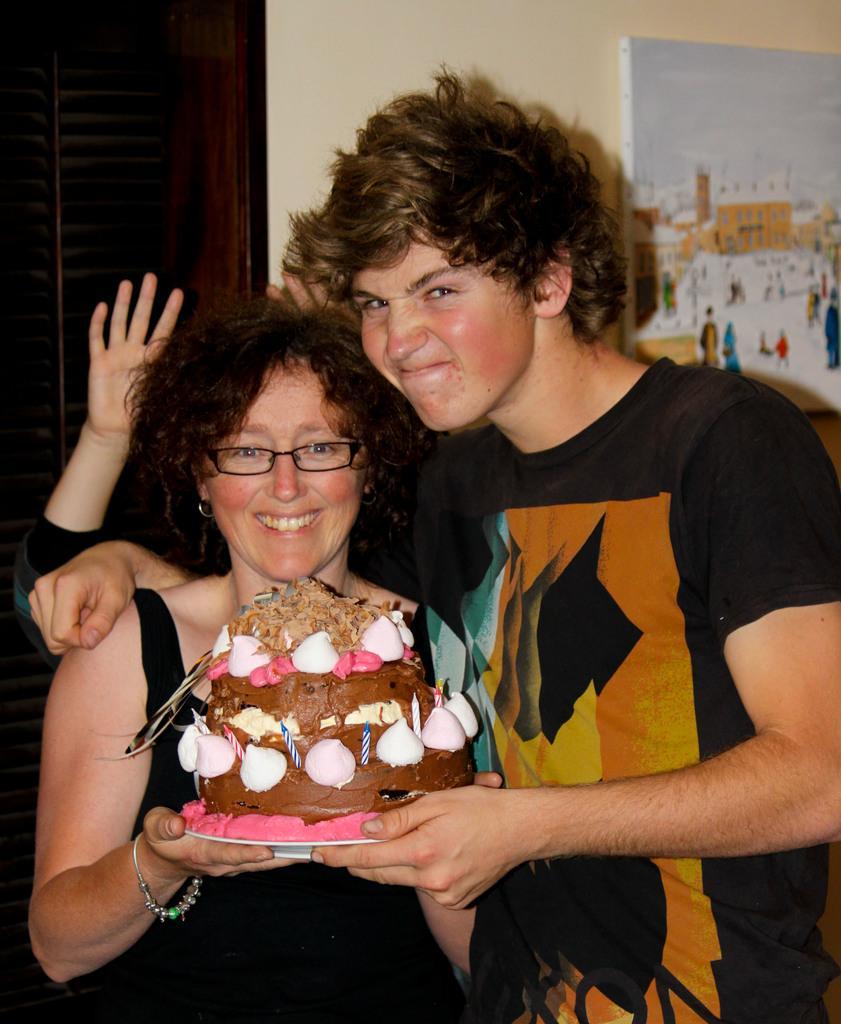How would you summarize this image in a sentence or two? In this picture there is a girl and a boy in the center of the image, by holding a cake in their hands, there is a poster on the right side of the image and there is a door on the left side of the image. 